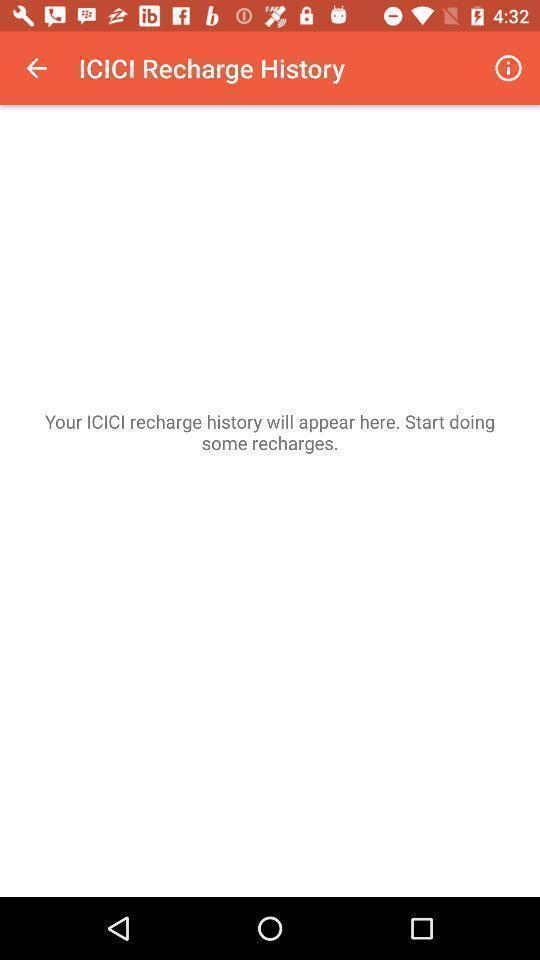Explain the elements present in this screenshot. Screen shows about a recharge history. 